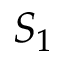Convert formula to latex. <formula><loc_0><loc_0><loc_500><loc_500>S _ { 1 }</formula> 